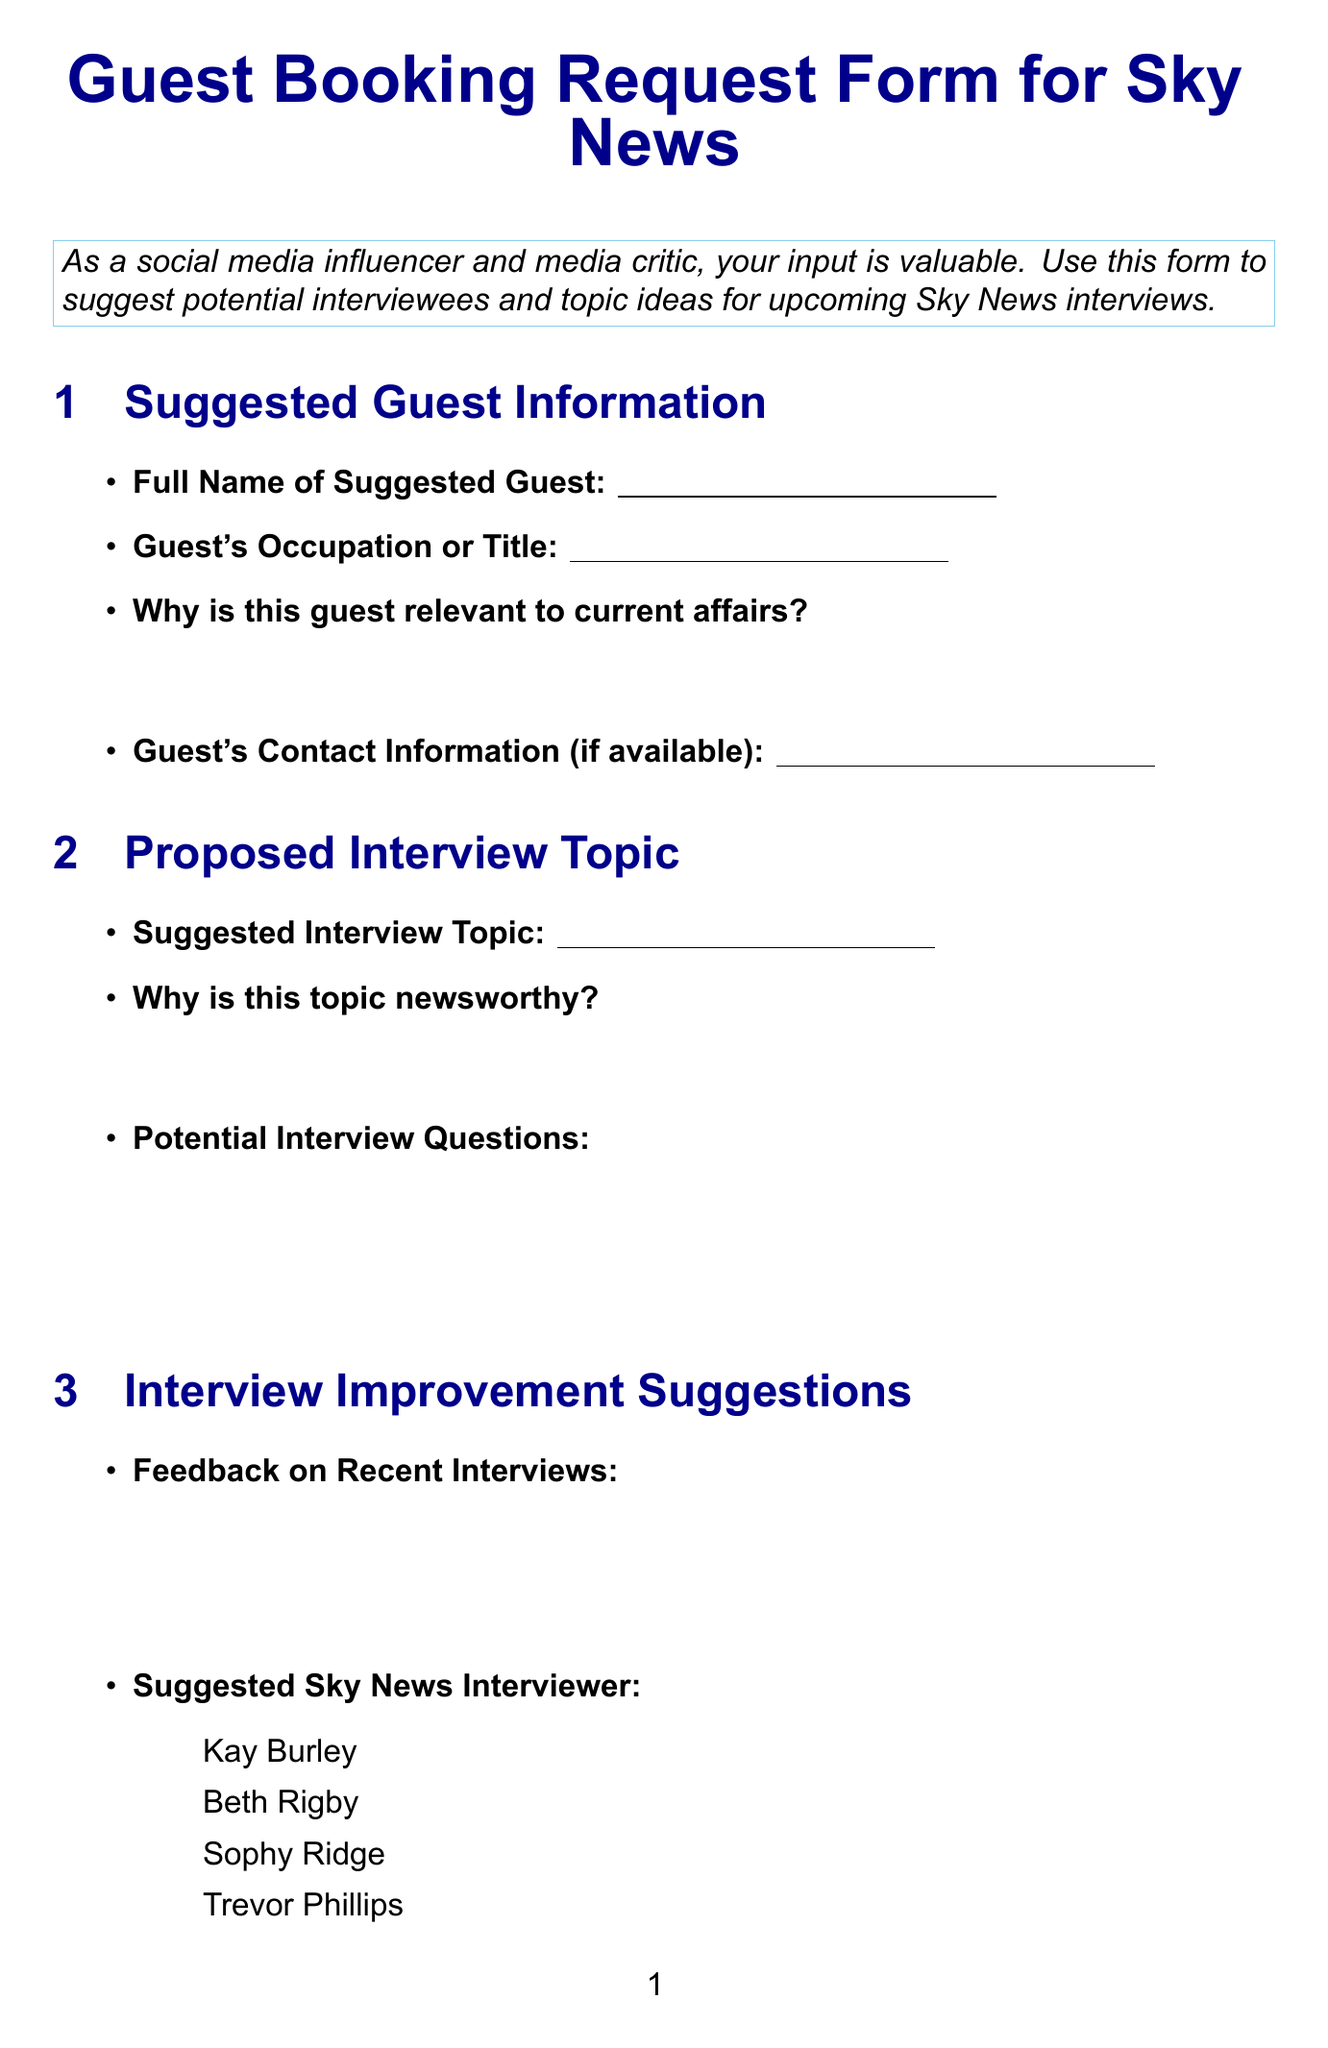what is the title of the form? The title of the form is stated at the top of the document.
Answer: Guest Booking Request Form for Sky News who is the target audience of the form? The form is designed for a specific group who will provide feedback.
Answer: social media influencers and media critics what is the placeholder text for the suggested interview topic? Each field has an example or prompt for the user to fill in.
Answer: e.g., The Future of Global Education Post-Pandemic how many potential interview questions should be listed? The form specifies a range for the number of questions expected.
Answer: 3-5 which section includes feedback on recent interviews? This section is focused on providing critique of prior interviews.
Answer: Interview Improvement Suggestions what are the names of two suggested Sky News interviewers? The form includes a selection of interviewers available for suggestion.
Answer: Kay Burley, Beth Rigby what is one of the required fields in the "Your Information" section? This section requires personal details about the influencer filling out the form.
Answer: Your Full Name why is it important to suggest a relevant guest? This field is included to ensure the guest connects with current news issues.
Answer: Explain how this guest's expertise relates to ongoing news stories or societal issues 